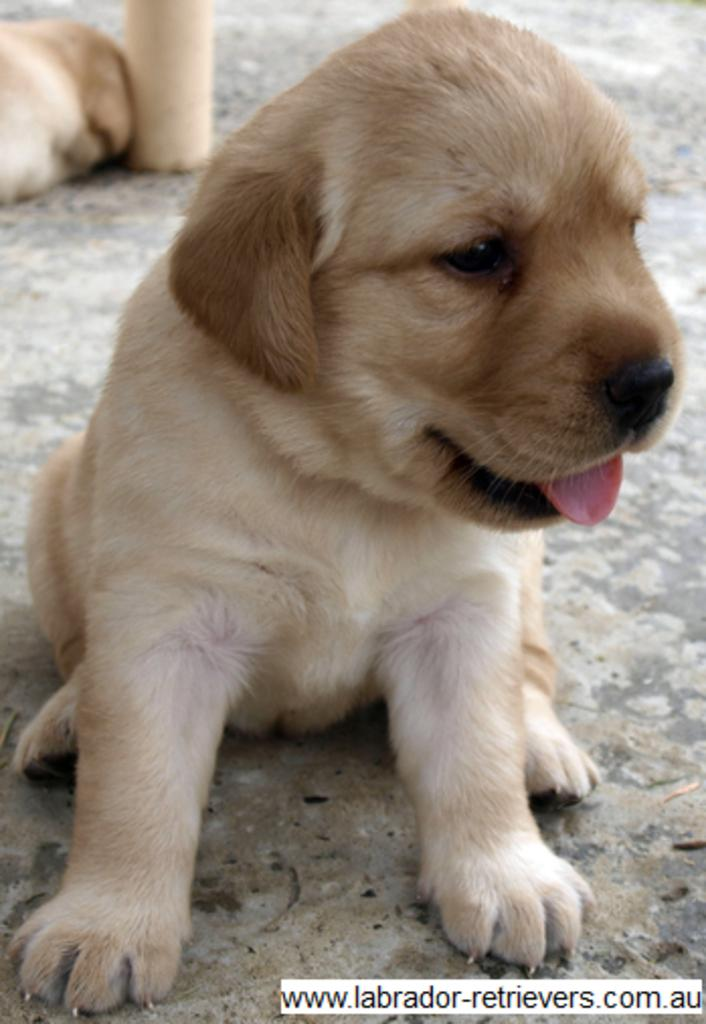What type of animals are present in the image? There are dogs in the image. Can you describe any additional features or elements in the image? There is a watermark at the right bottom of the image. What type of meal is being prepared by the queen in the image? There is no queen or meal preparation present in the image; it features dogs and a watermark. 